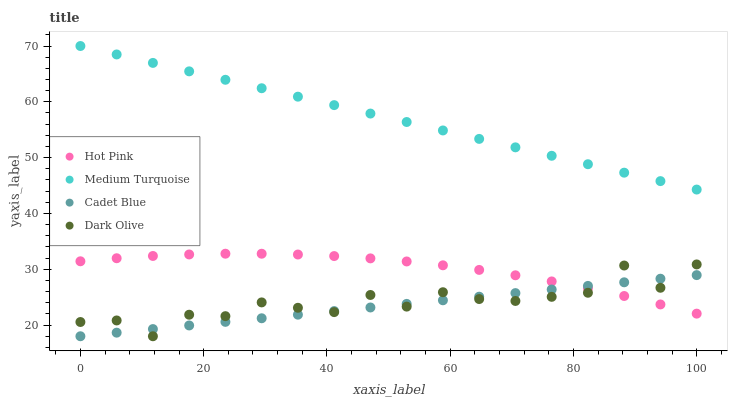Does Cadet Blue have the minimum area under the curve?
Answer yes or no. Yes. Does Medium Turquoise have the maximum area under the curve?
Answer yes or no. Yes. Does Hot Pink have the minimum area under the curve?
Answer yes or no. No. Does Hot Pink have the maximum area under the curve?
Answer yes or no. No. Is Cadet Blue the smoothest?
Answer yes or no. Yes. Is Dark Olive the roughest?
Answer yes or no. Yes. Is Hot Pink the smoothest?
Answer yes or no. No. Is Hot Pink the roughest?
Answer yes or no. No. Does Cadet Blue have the lowest value?
Answer yes or no. Yes. Does Hot Pink have the lowest value?
Answer yes or no. No. Does Medium Turquoise have the highest value?
Answer yes or no. Yes. Does Hot Pink have the highest value?
Answer yes or no. No. Is Cadet Blue less than Medium Turquoise?
Answer yes or no. Yes. Is Medium Turquoise greater than Cadet Blue?
Answer yes or no. Yes. Does Dark Olive intersect Cadet Blue?
Answer yes or no. Yes. Is Dark Olive less than Cadet Blue?
Answer yes or no. No. Is Dark Olive greater than Cadet Blue?
Answer yes or no. No. Does Cadet Blue intersect Medium Turquoise?
Answer yes or no. No. 